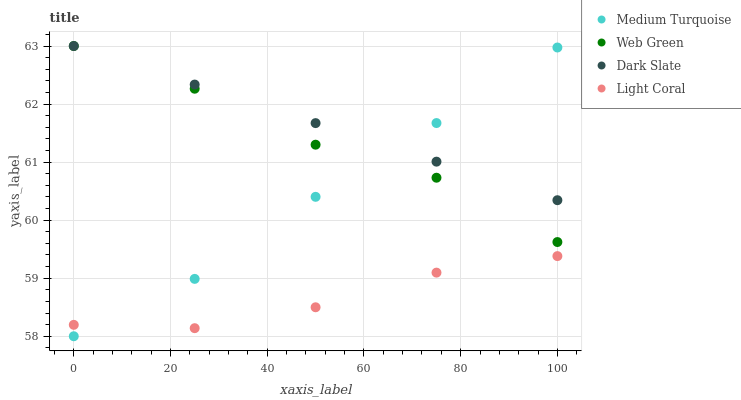Does Light Coral have the minimum area under the curve?
Answer yes or no. Yes. Does Dark Slate have the maximum area under the curve?
Answer yes or no. Yes. Does Web Green have the minimum area under the curve?
Answer yes or no. No. Does Web Green have the maximum area under the curve?
Answer yes or no. No. Is Dark Slate the smoothest?
Answer yes or no. Yes. Is Web Green the roughest?
Answer yes or no. Yes. Is Web Green the smoothest?
Answer yes or no. No. Is Dark Slate the roughest?
Answer yes or no. No. Does Medium Turquoise have the lowest value?
Answer yes or no. Yes. Does Web Green have the lowest value?
Answer yes or no. No. Does Web Green have the highest value?
Answer yes or no. Yes. Does Medium Turquoise have the highest value?
Answer yes or no. No. Is Light Coral less than Web Green?
Answer yes or no. Yes. Is Dark Slate greater than Light Coral?
Answer yes or no. Yes. Does Medium Turquoise intersect Light Coral?
Answer yes or no. Yes. Is Medium Turquoise less than Light Coral?
Answer yes or no. No. Is Medium Turquoise greater than Light Coral?
Answer yes or no. No. Does Light Coral intersect Web Green?
Answer yes or no. No. 